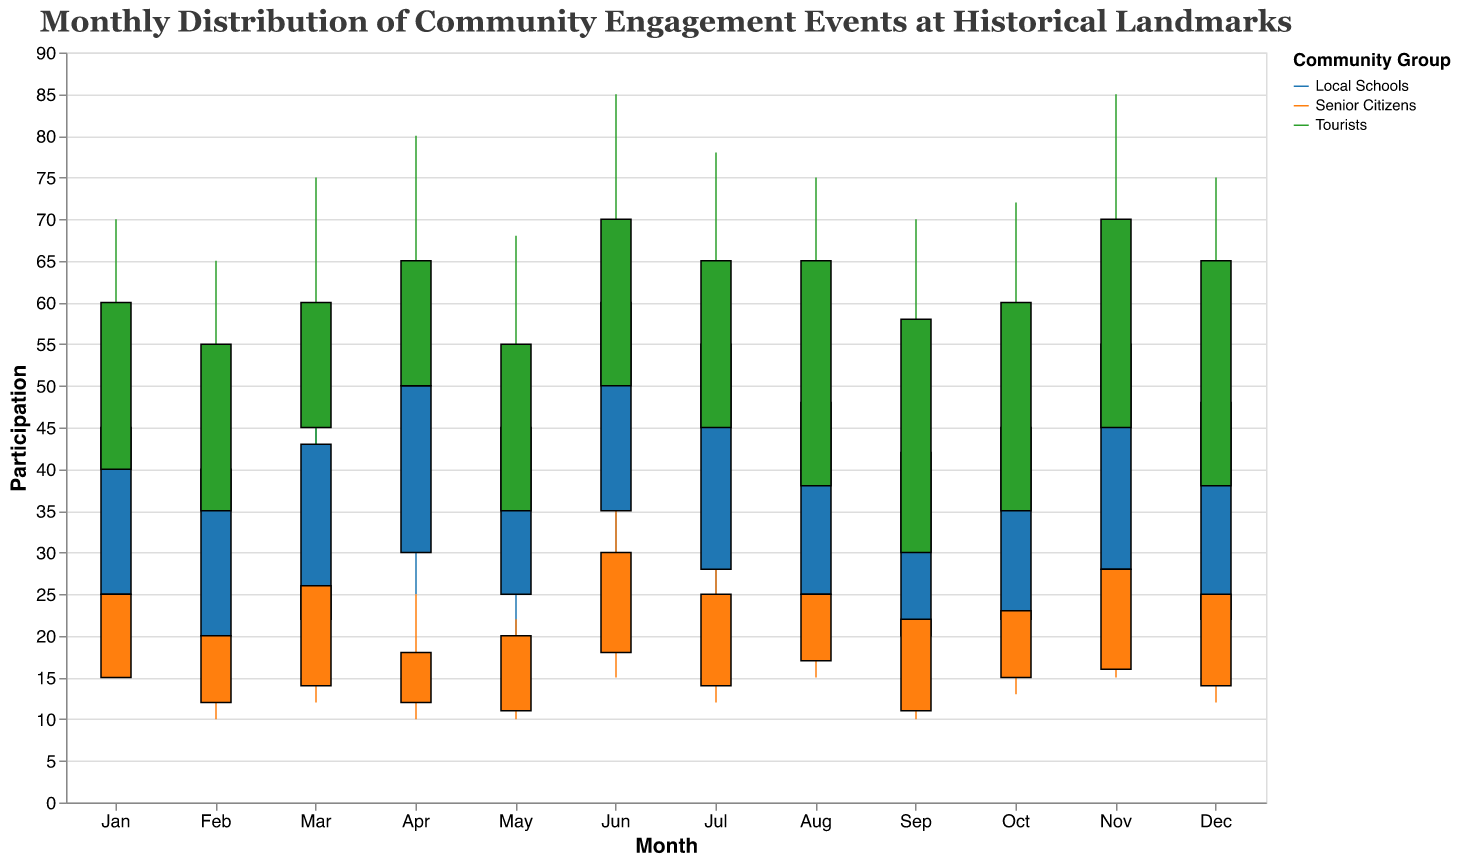What is the title of the figure? The title is located at the top of the candlestick plot. It reads "Monthly Distribution of Community Engagement Events at Historical Landmarks."
Answer: Monthly Distribution of Community Engagement Events at Historical Landmarks How many community groups are represented in the figure? The legend on the right side of the candlestick plot shows three distinct color indicators, each representing a different community group.
Answer: Three Which community group shows the highest maximum participation in December? To find this, look at the December data points and compare the maximum participation values. Tourists reach a maximum of 75.
Answer: Tourists During which month do Local Schools have the highest close participation? Scan the highest close participation for Local Schools across the months. June shows the highest value of 60 for Local Schools.
Answer: June How does the close participation of Senior Citizens in February compare to that in September? Look at the candlestick plots for Senior Citizens in both February and September. February's close participation is 20, and September's is 22.
Answer: February's is lower than September's What is the average close participation for Local Schools in the first quarter (Jan-Mar)? Sum the close participation values for Local Schools from January, February, and March, then divide by the number of months (43 + 40 + 43) / 3. This averages to 42.
Answer: 42 Which historical landmark has the most consistent (smallest range) participation for Tourists? Look at the difference between the Min and Max participation values for Tourists in each historic landmark. Alcatraz Island has the smallest range (68 - 28 = 40).
Answer: Alcatraz Island In which month and at which landmark do Local Schools and Tourists both have the same close participation value? Compare the close participation values for Local Schools and Tourists across all months and landmarks. In September at the Golden Gate Bridge, they both close at 42.
Answer: September, Golden Gate Bridge What is the median close participation value for all Tourist groups across the months? List the close participation values for Tourists across all months: 60, 55, 60, 65, 55, 70, 65, 65, 58, 60, 70, 65. The median is the middle value of the sorted list: 60, 55, 60, 65, 55, 70, 65, 65, 58, 60, 70, 65. The two middle values are 65 and 65, giving a median of 65.
Answer: 65 